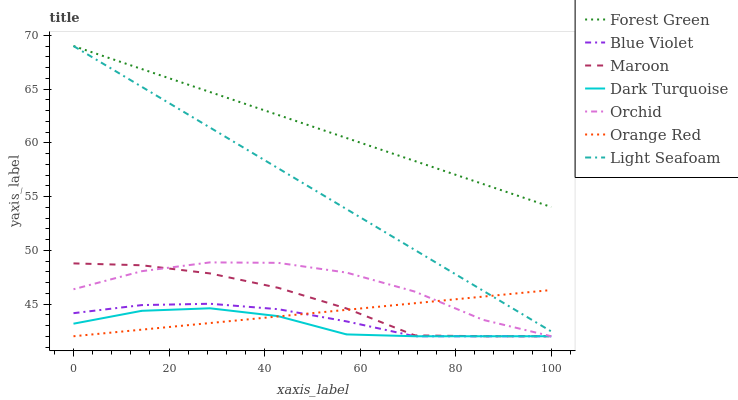Does Dark Turquoise have the minimum area under the curve?
Answer yes or no. Yes. Does Forest Green have the maximum area under the curve?
Answer yes or no. Yes. Does Maroon have the minimum area under the curve?
Answer yes or no. No. Does Maroon have the maximum area under the curve?
Answer yes or no. No. Is Light Seafoam the smoothest?
Answer yes or no. Yes. Is Orchid the roughest?
Answer yes or no. Yes. Is Maroon the smoothest?
Answer yes or no. No. Is Maroon the roughest?
Answer yes or no. No. Does Forest Green have the lowest value?
Answer yes or no. No. Does Light Seafoam have the highest value?
Answer yes or no. Yes. Does Maroon have the highest value?
Answer yes or no. No. Is Orchid less than Light Seafoam?
Answer yes or no. Yes. Is Light Seafoam greater than Blue Violet?
Answer yes or no. Yes. Does Orchid intersect Light Seafoam?
Answer yes or no. No. 